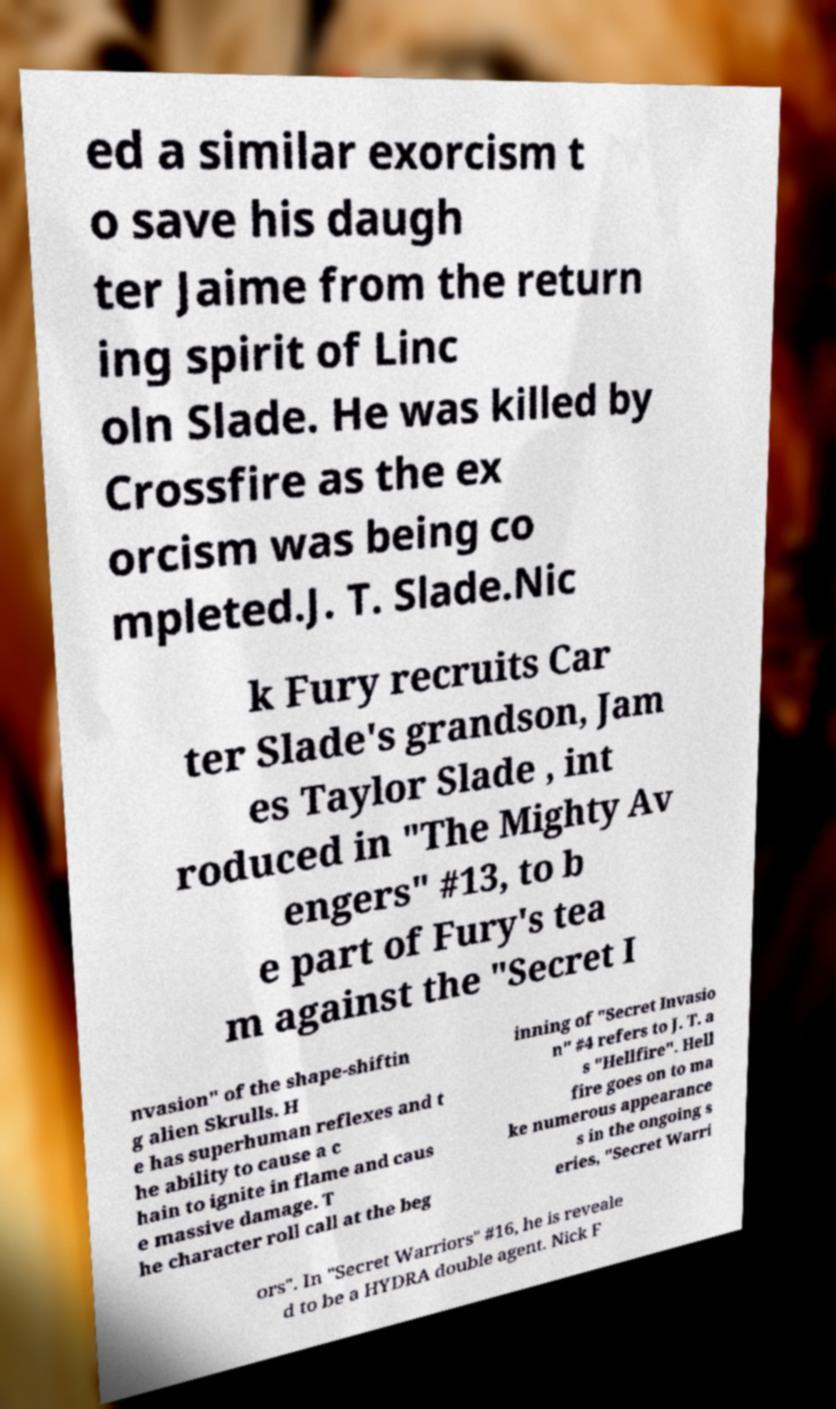Can you read and provide the text displayed in the image?This photo seems to have some interesting text. Can you extract and type it out for me? ed a similar exorcism t o save his daugh ter Jaime from the return ing spirit of Linc oln Slade. He was killed by Crossfire as the ex orcism was being co mpleted.J. T. Slade.Nic k Fury recruits Car ter Slade's grandson, Jam es Taylor Slade , int roduced in "The Mighty Av engers" #13, to b e part of Fury's tea m against the "Secret I nvasion" of the shape-shiftin g alien Skrulls. H e has superhuman reflexes and t he ability to cause a c hain to ignite in flame and caus e massive damage. T he character roll call at the beg inning of "Secret Invasio n" #4 refers to J. T. a s "Hellfire". Hell fire goes on to ma ke numerous appearance s in the ongoing s eries, "Secret Warri ors". In "Secret Warriors" #16, he is reveale d to be a HYDRA double agent. Nick F 